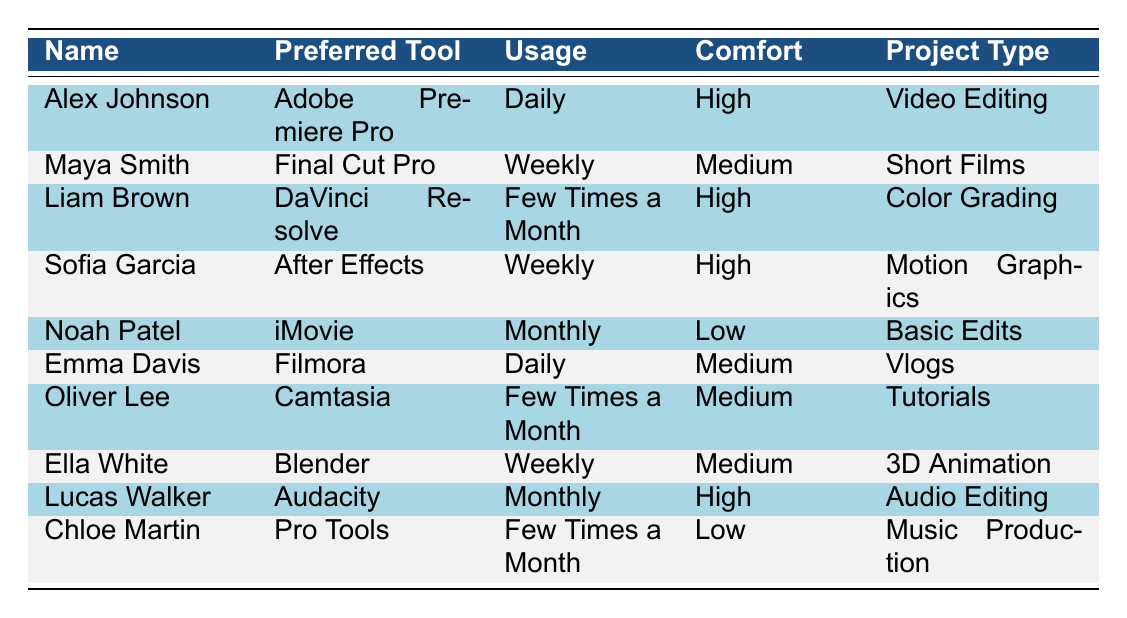What is the preferred tool of Liam Brown? Liam Brown's preferred tool is listed in the second column of his row, which is "DaVinci Resolve."
Answer: DaVinci Resolve How often does Emma Davis use her preferred tool? Emma Davis's usage frequency is found in the third column of her row, which states "Daily."
Answer: Daily Which student has the highest comfort level? To find the student with the highest comfort level, we look for entries marked "High" in the comfort level column. Alex Johnson, Liam Brown, Sofia Garcia, and Lucas Walker all have "High" comfort levels. Thus, there are multiple students with this level of comfort.
Answer: Multiple students How many students prefer tools that require "Weekly" usage? By counting the rows where the usage frequency is "Weekly," we see that Maya Smith, Sofia Garcia, and Ella White each prefer a tool with this frequency, totaling three students.
Answer: Three Is Noah Patel's comfort level medium? Noah Patel's comfort level, as seen in the table, is "Low," not medium. Thus, the answer is false.
Answer: No What is the project type for Chloe Martin? Chloe Martin's project type is found in the last column of her row, which shows "Music Production."
Answer: Music Production Among the students who use their tools daily, which project types are represented? The daily users are Alex Johnson and Emma Davis, who have project types "Video Editing" and "Vlogs," respectively. Therefore, both project types are represented by daily users.
Answer: Video Editing and Vlogs Is there a student whose comfort level is low and uses their tool monthly? Noah Patel fits this criterion as he has a "Low" comfort level and uses "iMovie" on a monthly basis, confirming the statement to be true.
Answer: Yes What percentage of students are comfortable with their preferred tools? There are 10 students in total. Four of them have a "High" comfort level, which equates to a percentage of (4/10)*100 = 40%. Thus, the percentage of students comfortable with their preferred tools is 40%.
Answer: 40% 